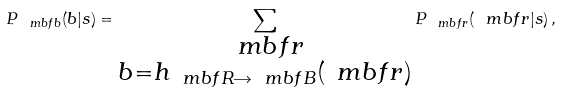Convert formula to latex. <formula><loc_0><loc_0><loc_500><loc_500>P _ { \ m b f { b } } ( b | s ) = \sum _ { \substack { \ m b f { r } \\ b = h _ { \ m b f { R } \rightarrow \ m b f { B } } ( \ m b f { r } ) } } { P _ { \ m b f { r } } ( \ m b f { r } | s ) } \, ,</formula> 